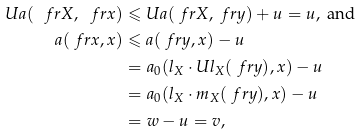Convert formula to latex. <formula><loc_0><loc_0><loc_500><loc_500>U a ( \ f r X , \ f r x ) & \leqslant U a ( \ f r X , \ f r y ) + u = u , \text { and} \\ a ( \ f r x , x ) & \leqslant a ( \ f r y , x ) - u \\ & = a _ { 0 } ( l _ { X } \cdot U l _ { X } ( \ f r y ) , x ) - u \\ & = a _ { 0 } ( l _ { X } \cdot m _ { X } ( \ f r y ) , x ) - u \\ & = w - u = v ,</formula> 